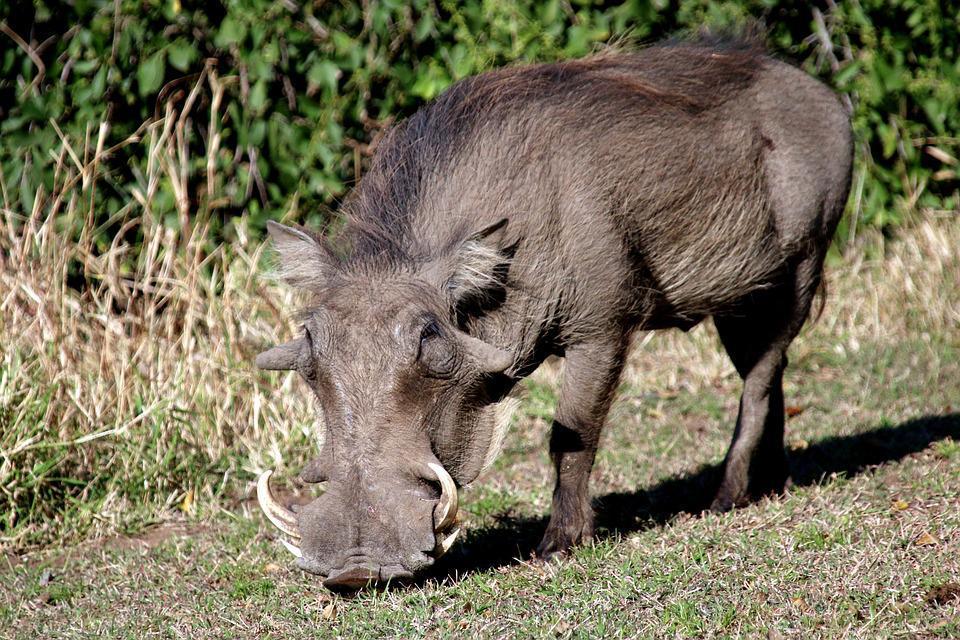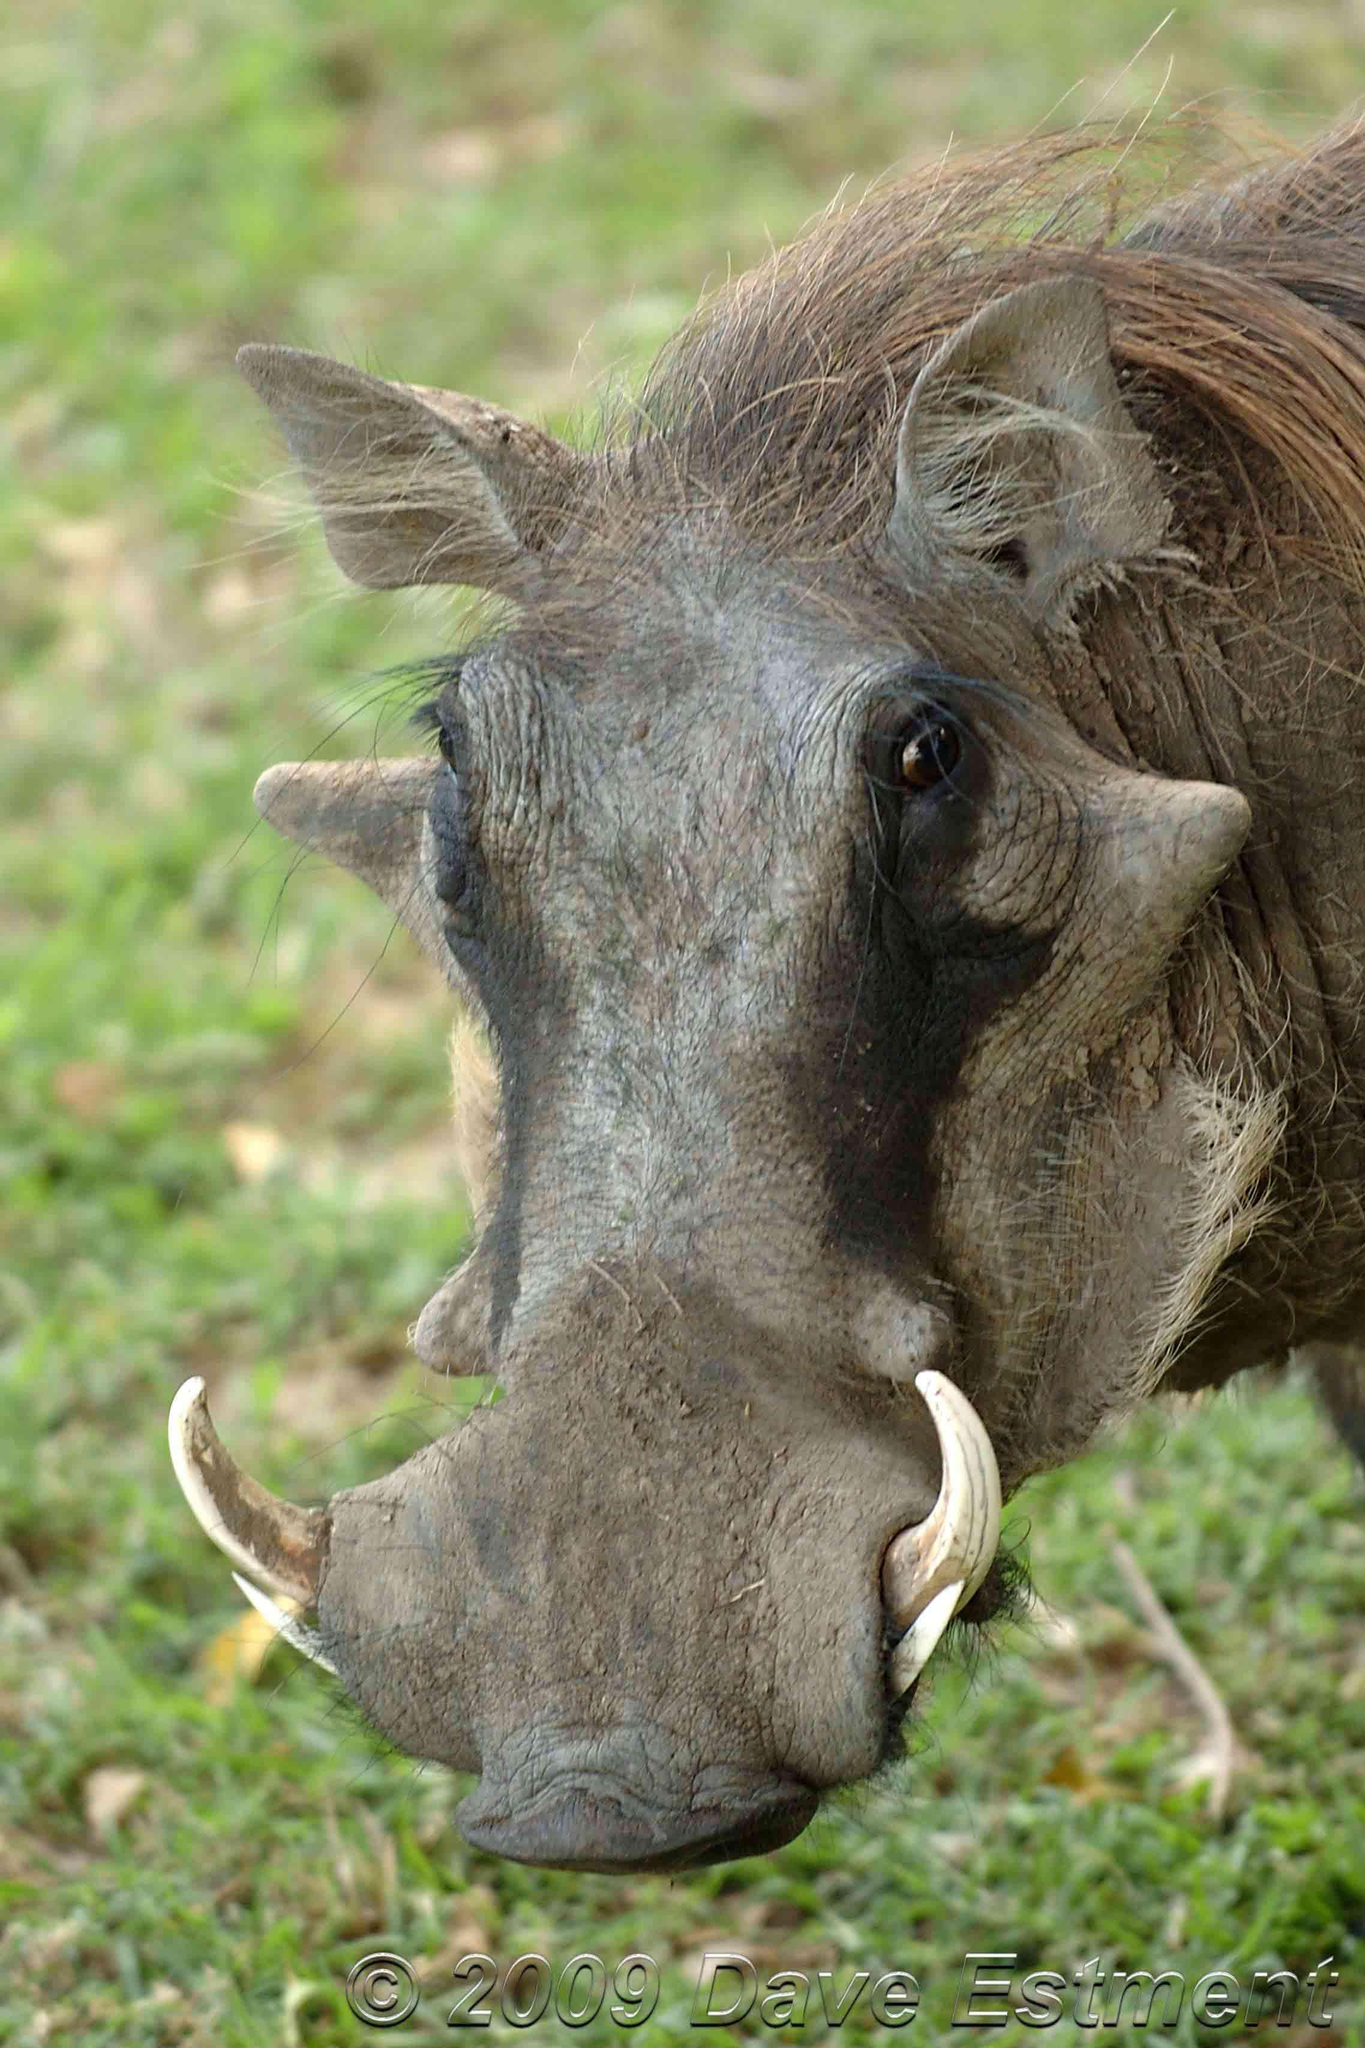The first image is the image on the left, the second image is the image on the right. Considering the images on both sides, is "The animals in the image on the right are eating grass." valid? Answer yes or no. No. 